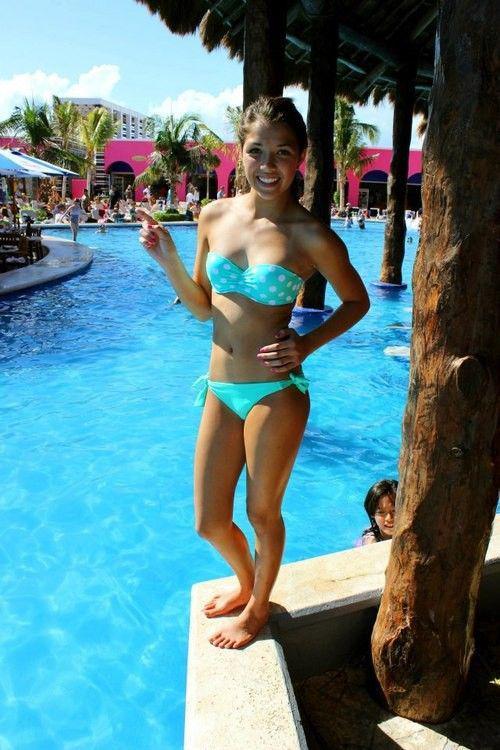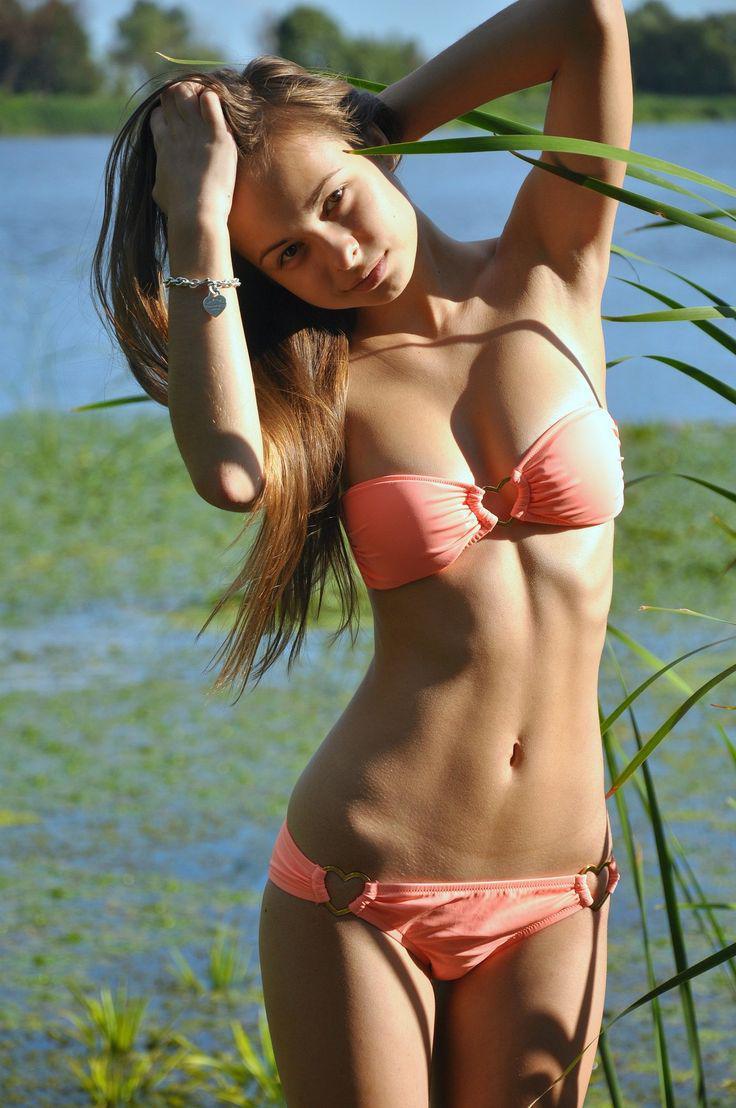The first image is the image on the left, the second image is the image on the right. Evaluate the accuracy of this statement regarding the images: "All of the models are shown from the front, and are wearing tops that can be seen to loop around the neck.". Is it true? Answer yes or no. No. The first image is the image on the left, the second image is the image on the right. Considering the images on both sides, is "The woman on the left has on a light blue bikini." valid? Answer yes or no. Yes. 